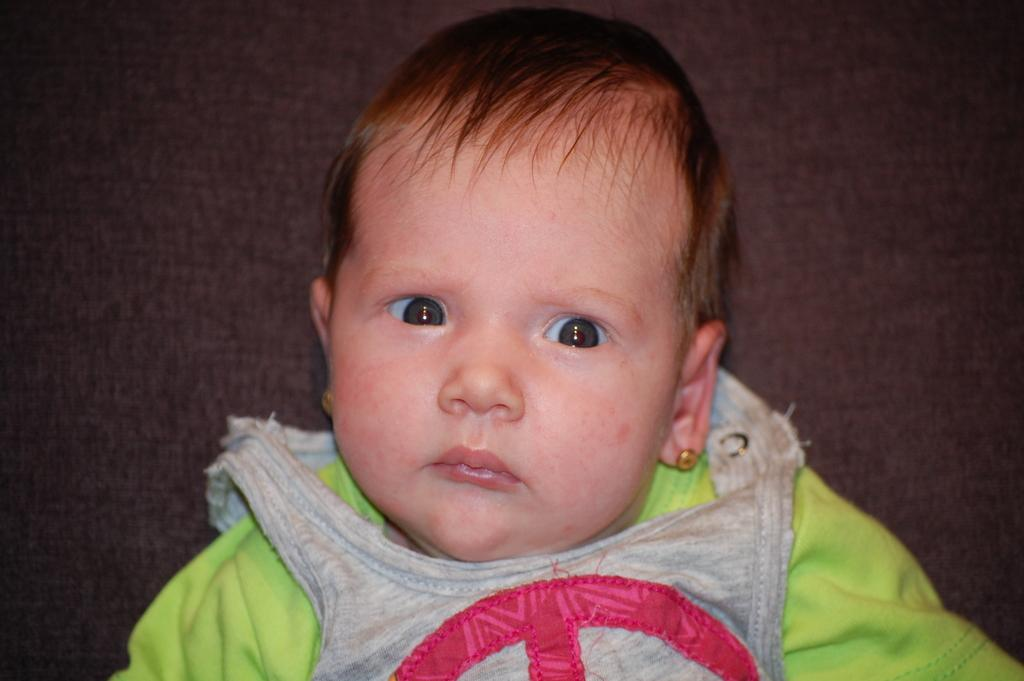What is the main subject of the image? There is a toddler in the image. What is the toddler doing in the image? The toddler is sitting on a couch. Can you describe the surrounding environment in the image? There is another couch behind the toddler. How long does it take for the queen to expand in the image? There is no queen present in the image, and therefore no expansion can be observed. 